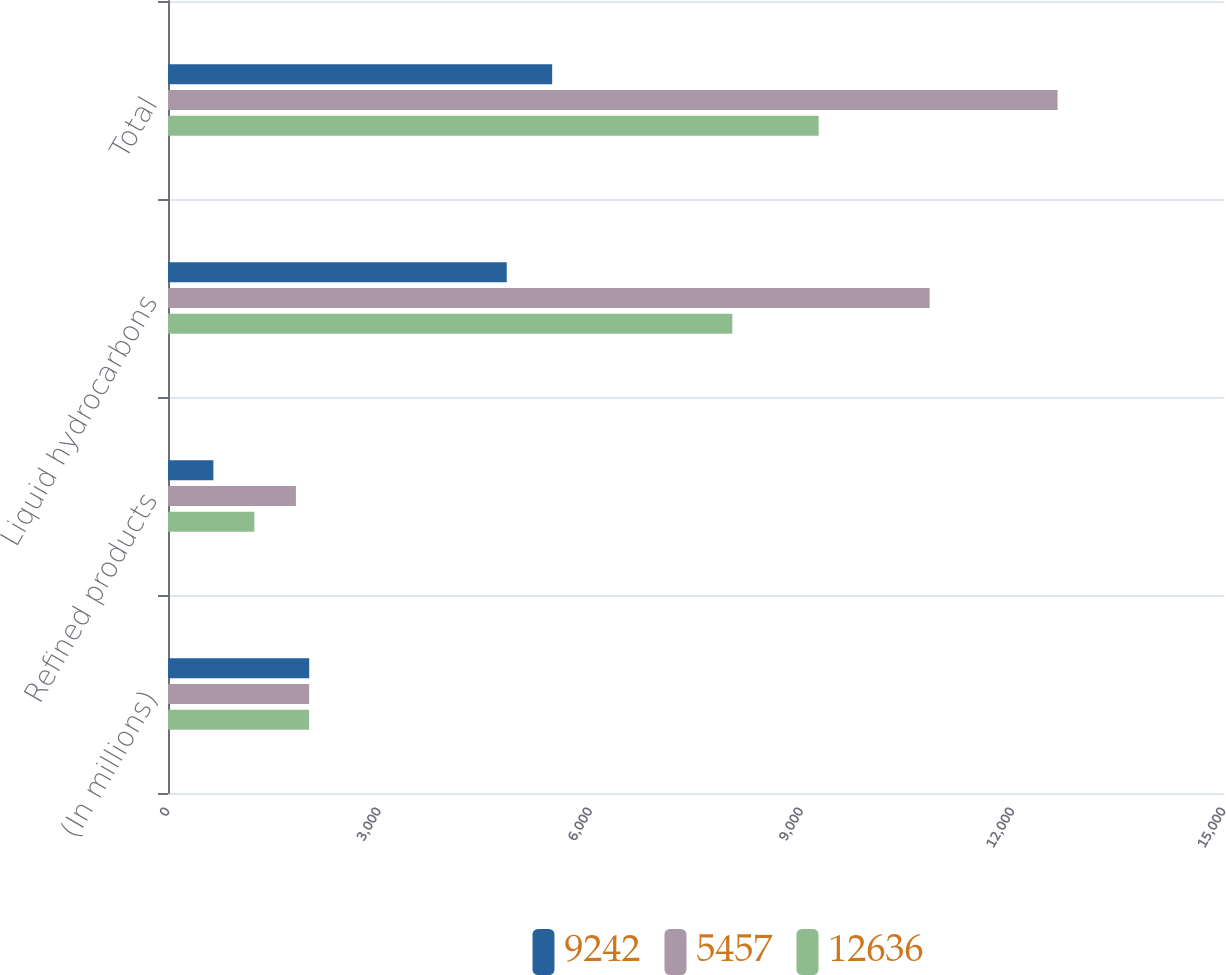<chart> <loc_0><loc_0><loc_500><loc_500><stacked_bar_chart><ecel><fcel>(In millions)<fcel>Refined products<fcel>Liquid hydrocarbons<fcel>Total<nl><fcel>9242<fcel>2006<fcel>645<fcel>4812<fcel>5457<nl><fcel>5457<fcel>2005<fcel>1817<fcel>10819<fcel>12636<nl><fcel>12636<fcel>2004<fcel>1226<fcel>8016<fcel>9242<nl></chart> 